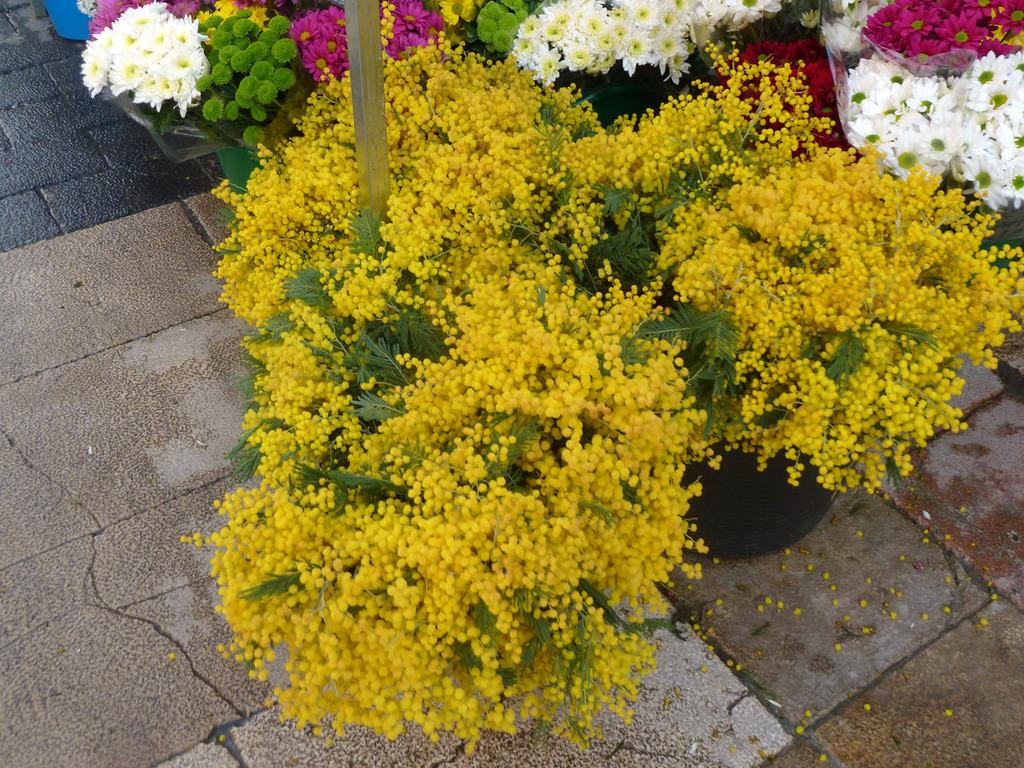What type of living organisms can be seen in the image? There are flowers and plants in the image. What else is present in the image besides the living organisms? There is a pole and a floor in the image. Can you describe the pole in the image? The pole is a vertical structure that stands upright. What is the surface that the plants and flowers are resting on? The floor is the surface that the plants and flowers are resting on. What type of coil can be seen in the image? There is no coil present in the image. What stage of development are the plants in the image? The stage of development of the plants cannot be determined from the image alone. 